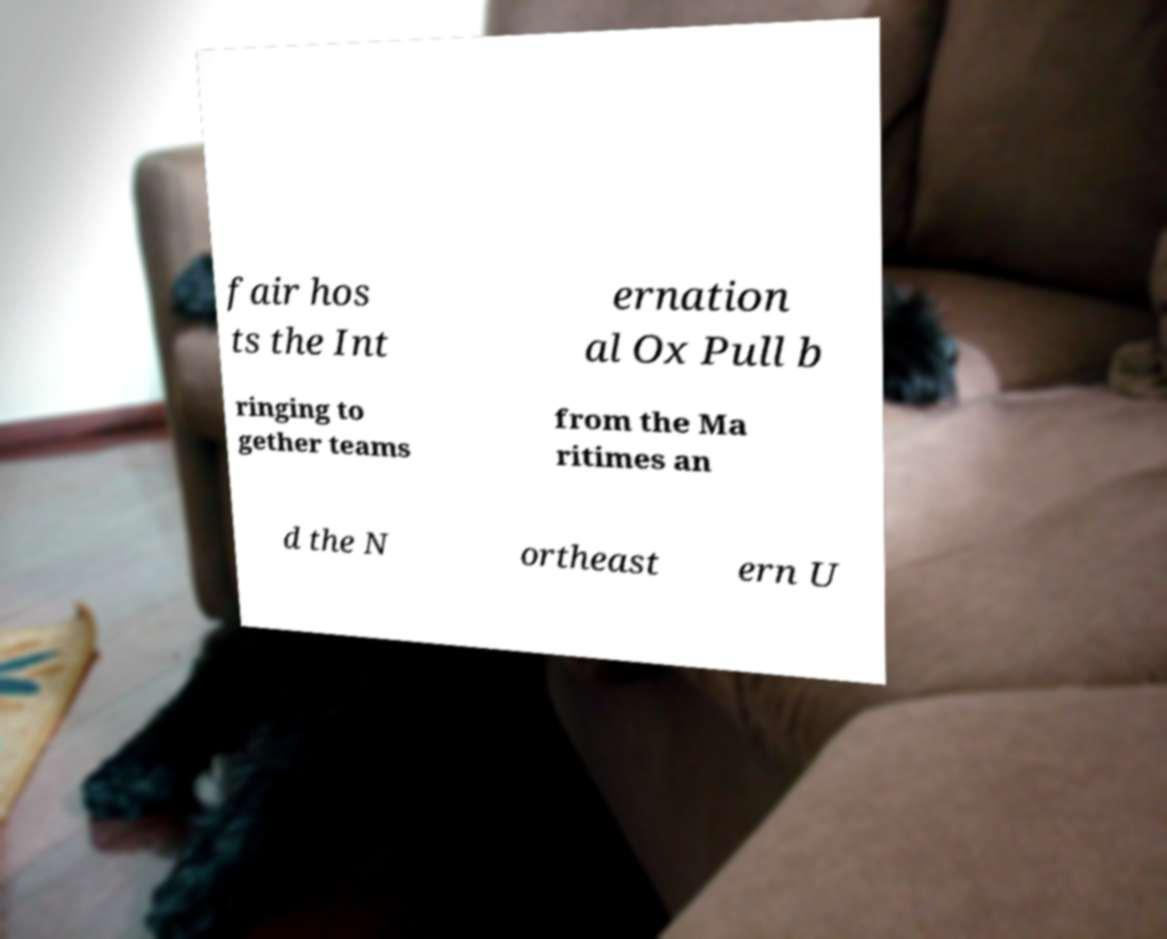I need the written content from this picture converted into text. Can you do that? fair hos ts the Int ernation al Ox Pull b ringing to gether teams from the Ma ritimes an d the N ortheast ern U 